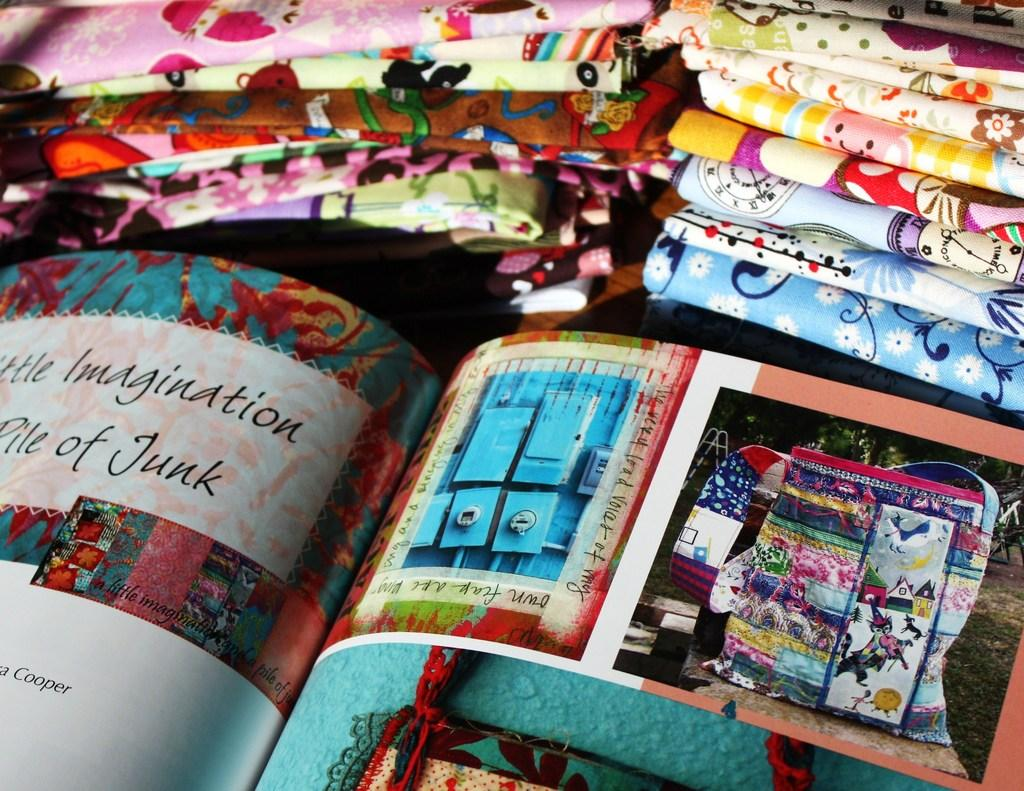What object can be seen in the image? There is a book in the image. What type of apparel is the book wearing in the image? Books do not wear apparel, as they are inanimate objects. 